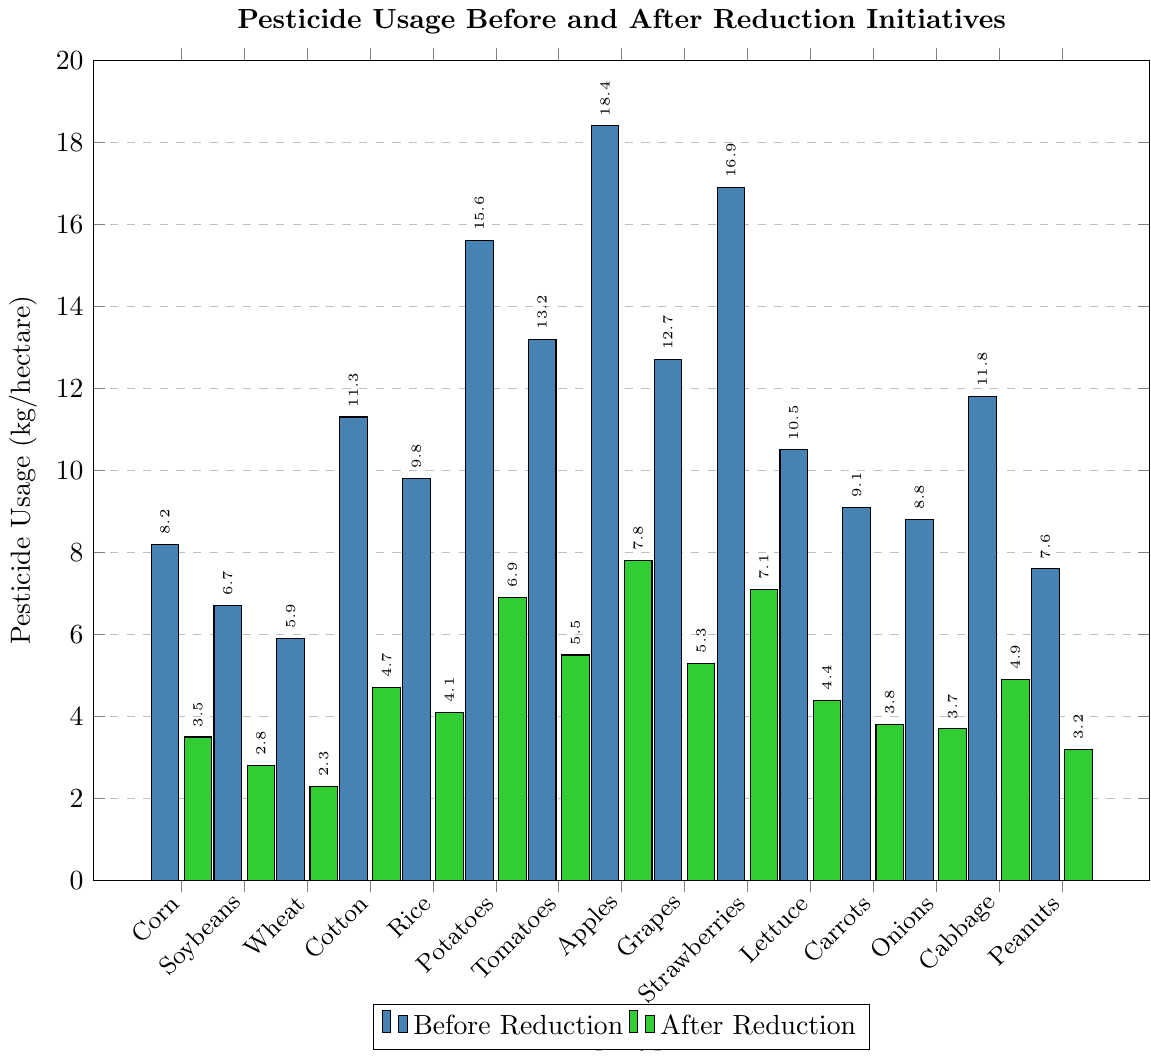What is the average pesticide usage before the reduction initiative across all crop types? To find the average, sum all the pesticide usage values before the reduction and divide by the total number of crop types. Sum = 8.2 + 6.7 + 5.9 + 11.3 + 9.8 + 15.6 + 13.2 + 18.4 + 12.7 + 16.9 + 10.5 + 9.1 + 8.8 + 11.8 + 7.6 = 176.5 kg/hectare. There are 15 crop types, so 176.5 / 15 ≈ 11.77 kg/hectare.
Answer: 11.77 What is the difference in pesticide usage for Apples before and after the reduction initiative? Subtract the pesticide usage after the reduction from the usage before the reduction for Apples. 18.4 - 7.8 = 10.6 kg/hectare.
Answer: 10.6 Which crop type had the highest reduction in pesticide usage? Find the difference between the values before and after the reduction for each crop type. The highest difference indicates the highest reduction. Differences are Corn: 4.7, Soybeans: 3.9, Wheat: 3.6, Cotton: 6.6, Rice: 5.7, Potatoes: 8.7, Tomatoes: 7.7, Apples: 10.6, Grapes: 7.4, Strawberries: 9.8, Lettuce: 6.1, Carrots: 5.3, Onions: 5.1, Cabbage: 6.9, Peanuts: 4.4. The highest reduction is Apples with 10.6 kg/hectare.
Answer: Apples Compare the total pesticide usage before and after the reduction initiative for Corn, Soybeans, and Wheat. Calculate the totals before and after for Corn, Soybeans, and Wheat. Before: 8.2 + 6.7 + 5.9 = 20.8 kg/hectare. After: 3.5 + 2.8 + 2.3 = 8.6 kg/hectare. The total reduction can be found by subtracting the after value from the before value. 20.8 - 8.6 = 12.2 kg/hectare. There was a total reduction of 12.2 kg/hectare.
Answer: 12.2 Which crop types still had pesticide usage greater than 5 kg/hectare after the reduction initiative? Review the bar heights for pesticide usage after the reduction and identify the crops with usage greater than 5 kg/hectare. They are Potatoes (6.9), Tomatoes (5.5), Apples (7.8), Strawberries (7.1), and Grapes (5.3).
Answer: Potatoes, Tomatoes, Apples, Strawberries, Grapes What is the overall percentage reduction in pesticide usage across all crop types? Calculate the total usage before and after the reduction, then find the percentage change. Total usage before = 176.5 kg/hectare, Total usage after = 70.1 kg/hectare. Reduction = 176.5 - 70.1 = 106.4 kg/hectare. Percentage reduction = (106.4 / 176.5) * 100 ≈ 60.3%.
Answer: 60.3% Which crop type had the smallest reduction in pesticide usage? Calculate the difference between the before and after values for each crop type and identify the smallest difference. Differences are Corn: 4.7, Soybeans: 3.9, Wheat: 3.6, Cotton: 6.6, Rice: 5.7, Potatoes: 8.7, Tomatoes: 7.7, Apples: 10.6, Grapes: 7.4, Strawberries: 9.8, Lettuce: 6.1, Carrots: 5.3, Onions: 5.1, Cabbage: 6.9, Peanuts: 4.4. The smallest reduction is Wheat with 3.6 kg/hectare.
Answer: Wheat What was the average pesticide usage after the reduction initiative for crops that had initial usage higher than 10 kg/hectare? Identify crops with initial usage higher than 10 kg/hectare and then calculate the average usage after the reduction. These crops are Cotton (4.7), Potatoes (6.9), Tomatoes (5.5), Apples (7.8), Grapes (5.3), and Strawberries (7.1). Sum after reduction = 4.7 + 6.9 + 5.5 + 7.8 + 5.3 + 7.1 = 37.3 kg/hectare. Number of crops = 6, so 37.3 / 6 ≈ 6.22 kg/hectare.
Answer: 6.22 What is the median pesticide usage after the reduction? List all the pesticide usage values after the reduction and find the median. Sorted values: 2.3, 2.8, 3.2, 3.5, 3.7, 3.8, 4.1, 4.4, 4.7, 4.9, 5.3, 5.5, 6.9, 7.1, 7.8. The median is the middle value, which is the 8th value, 4.4 kg/hectare.
Answer: 4.4 Which crop type had the highest pesticide usage before the reduction initiative? Identify the crop with the tallest bar in the "Before Reduction" series. Apples have the highest pesticide usage before the reduction with 18.4 kg/hectare.
Answer: Apples 